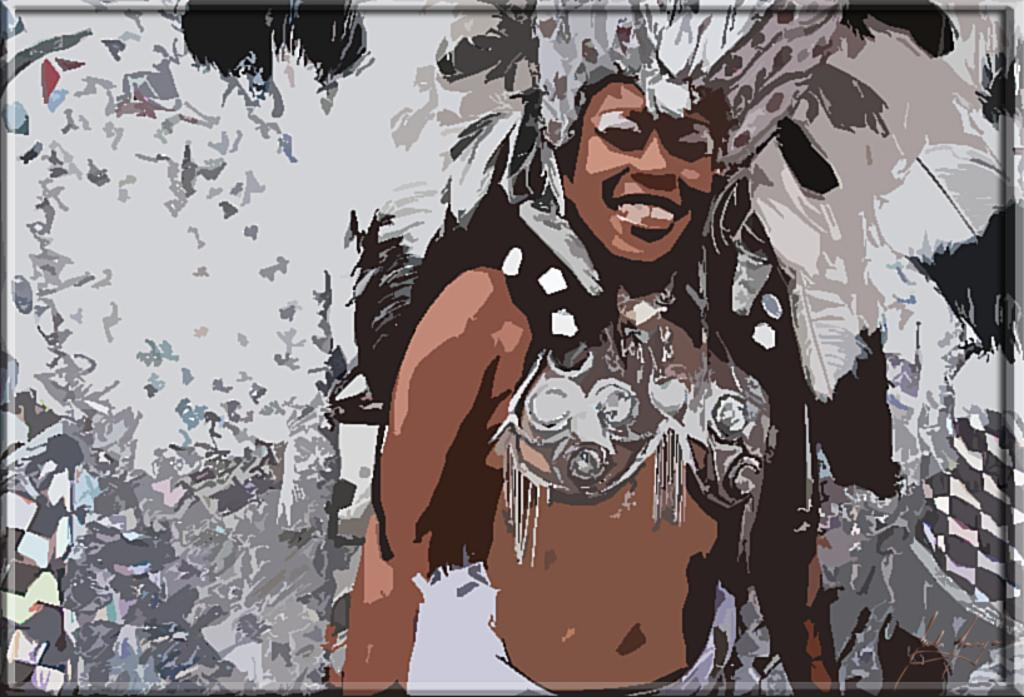What can be observed about the nature of the image? The image is edited. Who is present in the image? There is a woman in the image. What is the woman wearing in the image? The woman is wearing a carnival costume. What type of soup is being served in the scene? There is no soup present in the image, as the focus is on the woman wearing a carnival costume. 